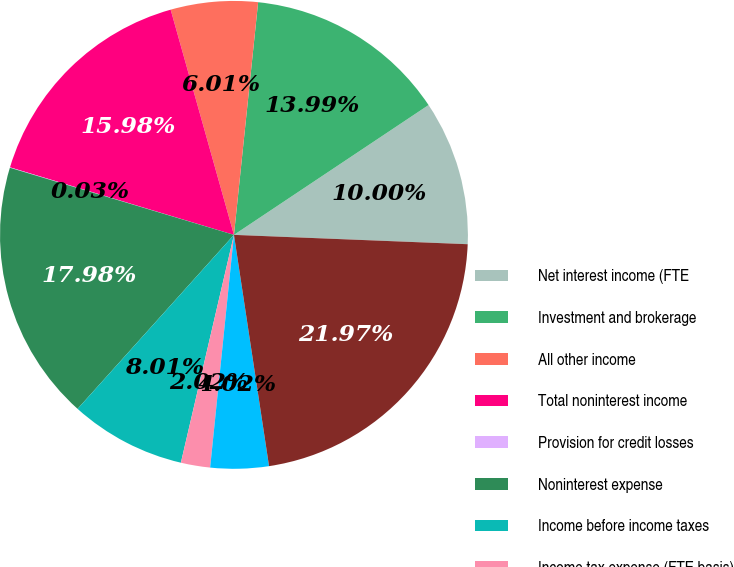Convert chart to OTSL. <chart><loc_0><loc_0><loc_500><loc_500><pie_chart><fcel>Net interest income (FTE<fcel>Investment and brokerage<fcel>All other income<fcel>Total noninterest income<fcel>Provision for credit losses<fcel>Noninterest expense<fcel>Income before income taxes<fcel>Income tax expense (FTE basis)<fcel>Net income<fcel>Total loans and leases<nl><fcel>10.0%<fcel>13.99%<fcel>6.01%<fcel>15.98%<fcel>0.03%<fcel>17.98%<fcel>8.01%<fcel>2.02%<fcel>4.02%<fcel>21.97%<nl></chart> 